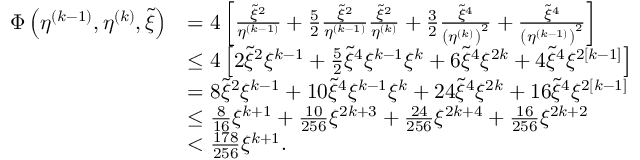Convert formula to latex. <formula><loc_0><loc_0><loc_500><loc_500>\begin{array} { r l } { \Phi \left ( \eta ^ { ( k - 1 ) } , \eta ^ { ( k ) } , \tilde { \xi } \right ) } & { = 4 \left [ \frac { \tilde { \xi } ^ { 2 } } { \eta ^ { ( k - 1 ) } } + \frac { 5 } { 2 } \frac { \tilde { \xi } ^ { 2 } } { \eta ^ { ( k - 1 ) } } \frac { \tilde { \xi } ^ { 2 } } { \eta ^ { ( k ) } } + \frac { 3 } { 2 } \frac { \tilde { \xi } ^ { 4 } } { \left ( \eta ^ { ( k ) } \right ) ^ { 2 } } + \frac { \tilde { \xi } ^ { 4 } } { \left ( \eta ^ { ( k - 1 ) } \right ) ^ { 2 } } \right ] } \\ & { \leq 4 \left [ 2 \tilde { \xi } ^ { 2 } \xi ^ { k - 1 } + \frac { 5 } { 2 } \tilde { \xi } ^ { 4 } \xi ^ { k - 1 } \xi ^ { k } + 6 \tilde { \xi } ^ { 4 } \xi ^ { 2 k } + 4 \tilde { \xi } ^ { 4 } \xi ^ { 2 [ k - 1 ] } \right ] } \\ & { = 8 \tilde { \xi } ^ { 2 } \xi ^ { k - 1 } + 1 0 \tilde { \xi } ^ { 4 } \xi ^ { k - 1 } \xi ^ { k } + 2 4 \tilde { \xi } ^ { 4 } \xi ^ { 2 k } + 1 6 \tilde { \xi } ^ { 4 } \xi ^ { 2 [ k - 1 ] } } \\ & { \leq \frac { 8 } { 1 6 } \xi ^ { k + 1 } + \frac { 1 0 } { 2 5 6 } \xi ^ { 2 k + 3 } + \frac { 2 4 } { 2 5 6 } \xi ^ { 2 k + 4 } + \frac { 1 6 } { 2 5 6 } \xi ^ { 2 k + 2 } } \\ & { < \frac { 1 7 8 } { 2 5 6 } \xi ^ { k + 1 } . } \end{array}</formula> 